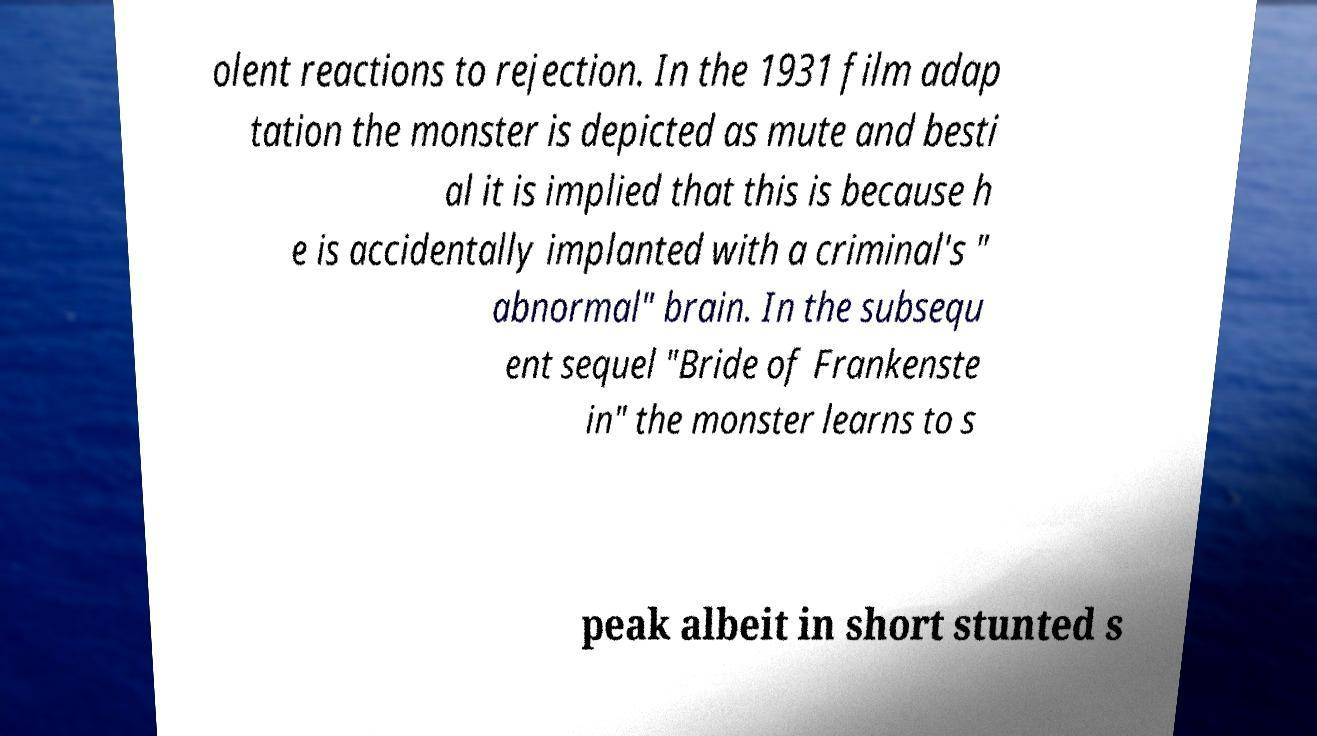Can you read and provide the text displayed in the image?This photo seems to have some interesting text. Can you extract and type it out for me? olent reactions to rejection. In the 1931 film adap tation the monster is depicted as mute and besti al it is implied that this is because h e is accidentally implanted with a criminal's " abnormal" brain. In the subsequ ent sequel "Bride of Frankenste in" the monster learns to s peak albeit in short stunted s 